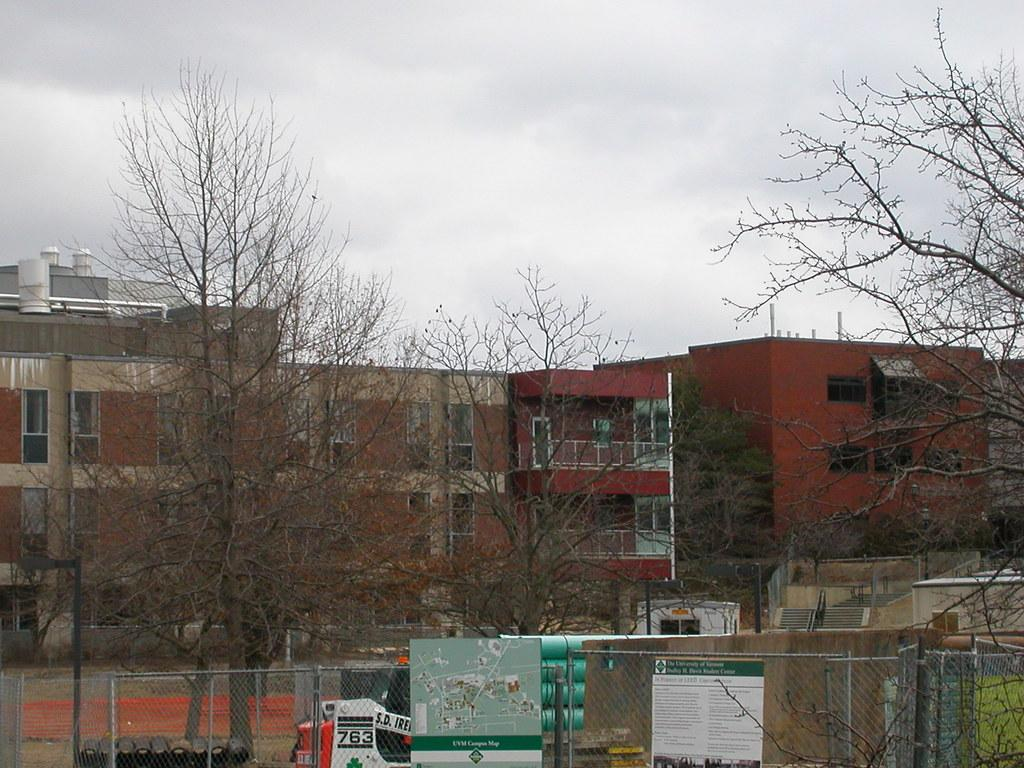What type of vegetation is present in the image? There are dry trees in the image. What can be seen in front of the dry trees? There is a mesh in the image. What is visible behind the mesh? There are many objects behind the mesh. What can be seen in the distance in the image? There are buildings in the background of the image. What type of prison can be seen in the image? There is no prison present in the image. How does the ladybug push the mesh in the image? There is no ladybug or pushing action present in the image. 